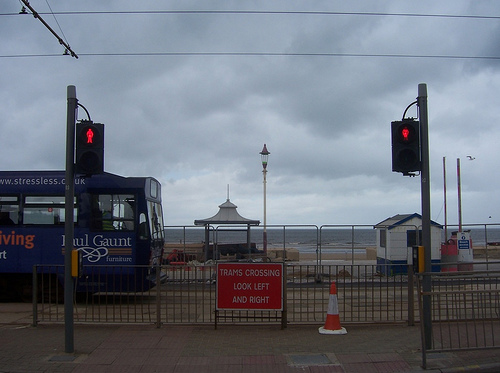Identify the text contained in this image. ww.stressless. ving Gaunt ul FURNITURE RIGHT AND LEFT LOOK CROSSING TRAMS rt 